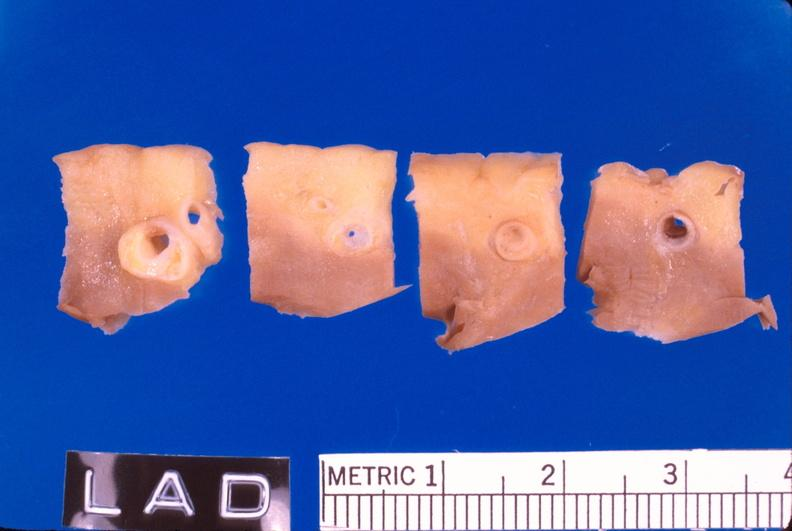what is present?
Answer the question using a single word or phrase. Vasculature 